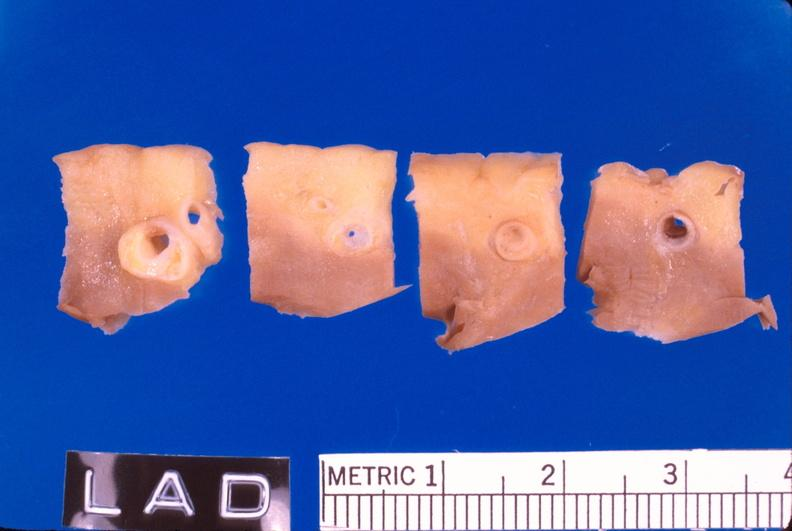what is present?
Answer the question using a single word or phrase. Vasculature 